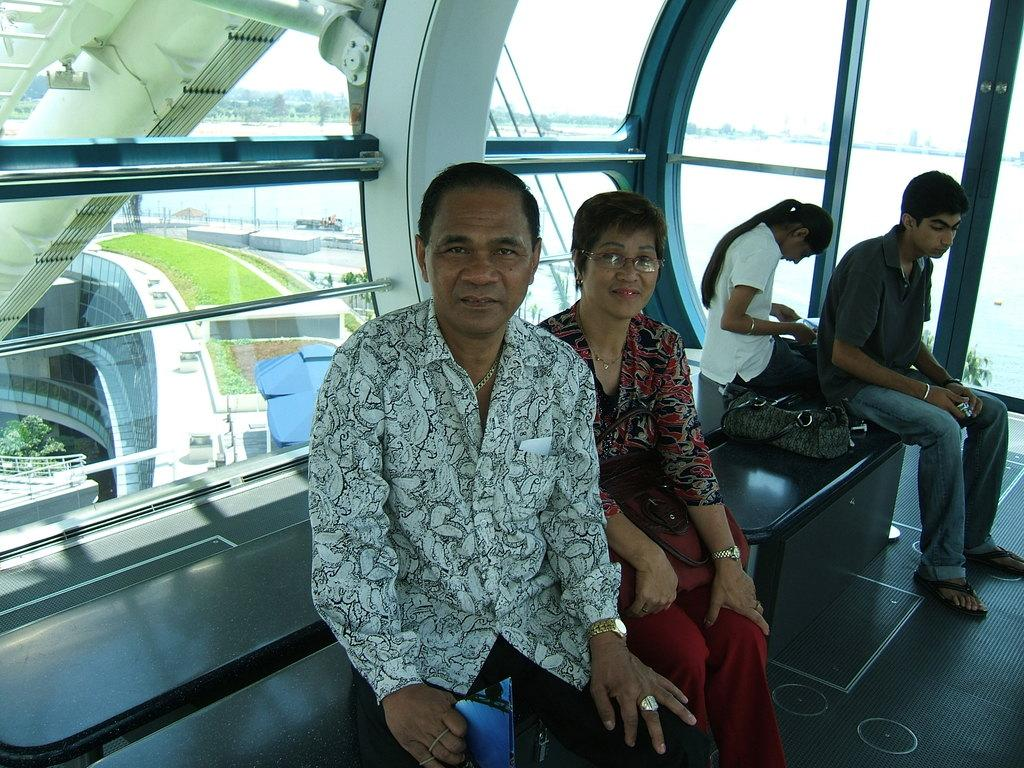How many people are in the image? There are persons in the image, but the exact number is not specified. What are the persons wearing? The persons are wearing clothes. What are the persons doing in the image? The persons are sitting on a bench. What can be seen on the right side of the image? There is a bag on the right side of the image. What is visible in the background of the image? There is a glass wall in the background of the image. What type of treatment is the owner giving to the persons in the image? There is no mention of an owner or any treatment in the image; the persons are simply sitting on a bench. 